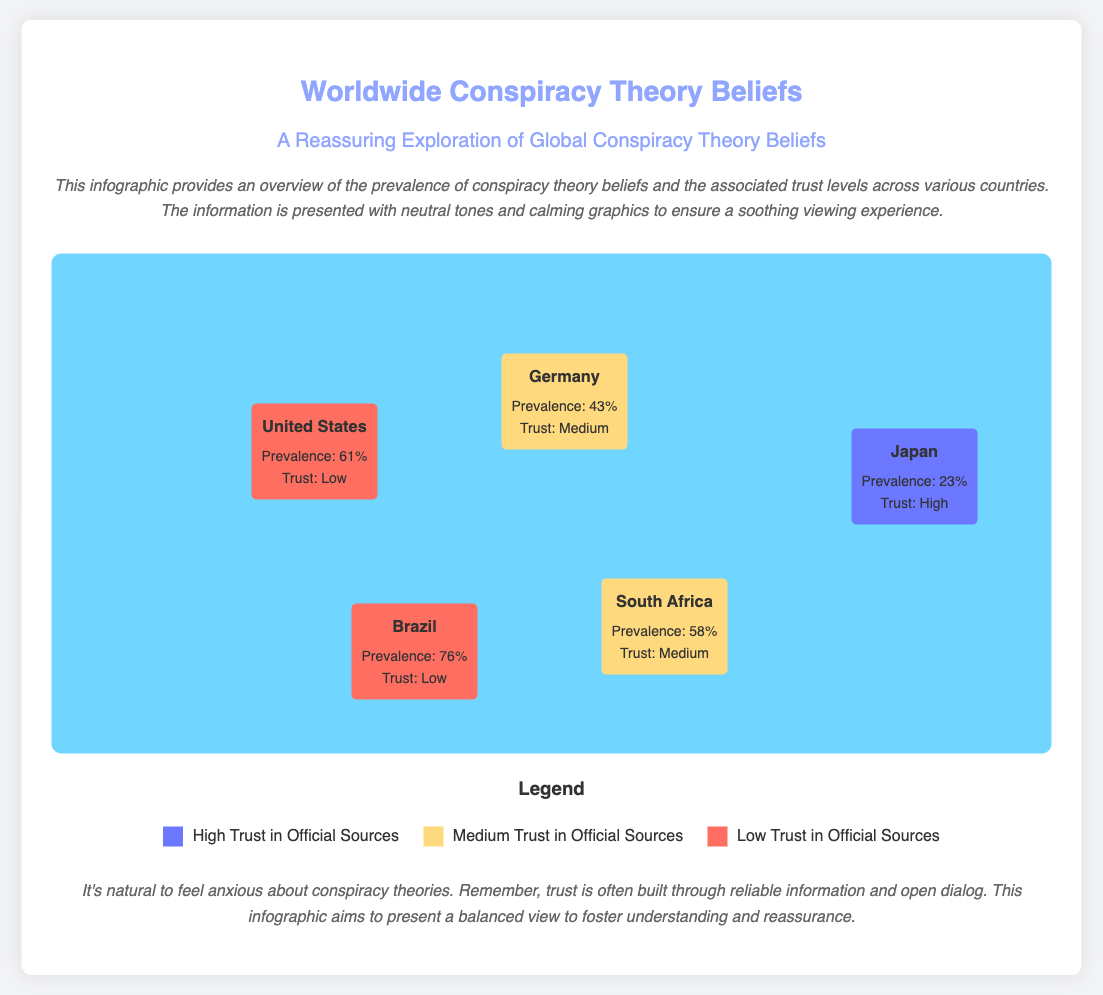What is the prevalence of conspiracy theory beliefs in the United States? The prevalence of conspiracy theory beliefs in the United States is listed in the document as 61%.
Answer: 61% What is the trust level associated with conspiracy theories in Brazil? The document states that Brazil has a low trust level in official sources regarding conspiracy theories.
Answer: Low Which country has the highest prevalence of conspiracy theory beliefs? The document indicates that Brazil has the highest prevalence of conspiracy theory beliefs at 76%.
Answer: 76% What color represents high trust in official sources in the legend? The legend in the document shows that high trust in official sources is represented by the color #6B78FF.
Answer: #6B78FF How many countries have a medium trust level according to the infographic? The infographic lists two countries with a medium trust level: Germany and South Africa.
Answer: 2 What is the prevalence of conspiracy theory beliefs in Japan? The document specifies that the prevalence of conspiracy theory beliefs in Japan is 23%.
Answer: 23% Which country has the lowest trust level? According to the document, both the United States and Brazil have a low trust level in official sources.
Answer: United States and Brazil What background color is used for the map in the infographic? The background color of the map in the infographic is a calming blue, specifically #70D6FF.
Answer: #70D6FF 